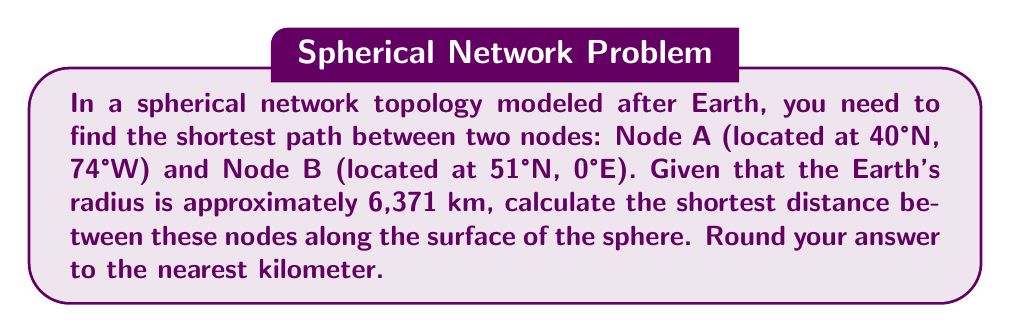Can you solve this math problem? To solve this problem, we'll use the great-circle distance formula, which calculates the shortest path between two points on a sphere. This is particularly relevant for a computer hacker working with global network topologies.

Step 1: Convert the coordinates to radians.
Node A: $\phi_1 = 40° \cdot \frac{\pi}{180} = 0.6981$ rad, $\lambda_1 = -74° \cdot \frac{\pi}{180} = -1.2915$ rad
Node B: $\phi_2 = 51° \cdot \frac{\pi}{180} = 0.8901$ rad, $\lambda_2 = 0° \cdot \frac{\pi}{180} = 0$ rad

Step 2: Calculate the central angle $\Delta\sigma$ using the Haversine formula:

$$\Delta\sigma = 2 \arcsin\left(\sqrt{\sin^2\left(\frac{\phi_2 - \phi_1}{2}\right) + \cos(\phi_1)\cos(\phi_2)\sin^2\left(\frac{\lambda_2 - \lambda_1}{2}\right)}\right)$$

Step 3: Substitute the values:

$$\Delta\sigma = 2 \arcsin\left(\sqrt{\sin^2\left(\frac{0.8901 - 0.6981}{2}\right) + \cos(0.6981)\cos(0.8901)\sin^2\left(\frac{0 - (-1.2915)}{2}\right)}\right)$$

Step 4: Calculate the result:

$$\Delta\sigma = 2 \arcsin(\sqrt{0.0046 + 0.5178}) = 2 \arcsin(\sqrt{0.5224}) = 2 \arcsin(0.7228) = 1.0214$$

Step 5: Calculate the distance $d$ using the formula:

$$d = R \cdot \Delta\sigma$$

Where $R$ is the Earth's radius (6,371 km).

$$d = 6,371 \cdot 1.0214 = 6,507.14 \text{ km}$$

Step 6: Round to the nearest kilometer:

$$d \approx 6,507 \text{ km}$$
Answer: 6,507 km 